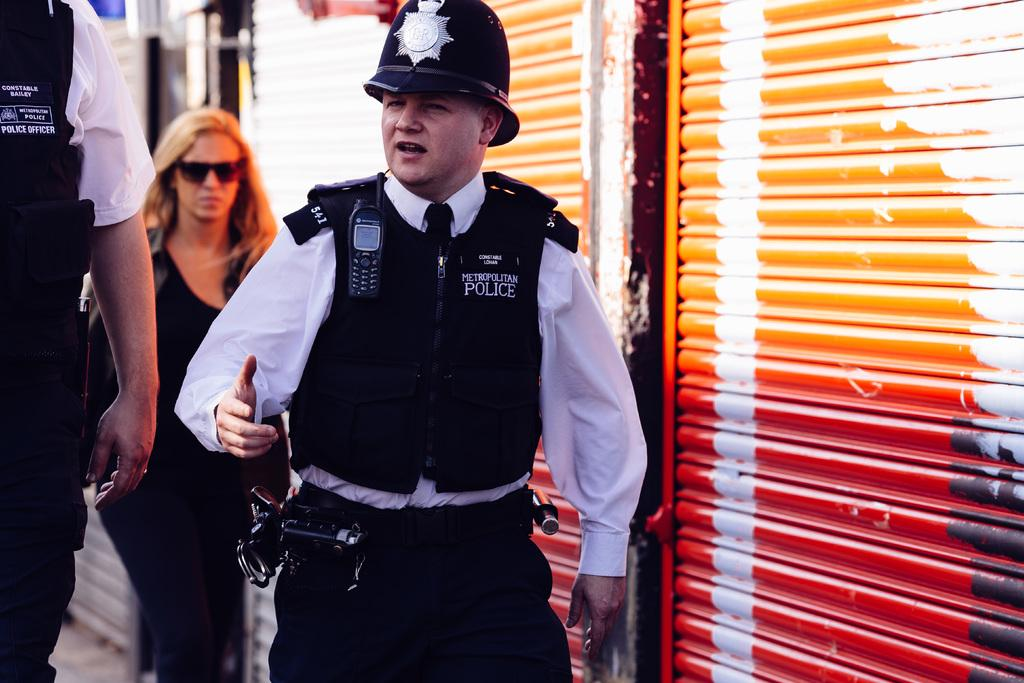How many policemen are in the image? There are two policemen in the image. What is the position of the woman in relation to the policemen? The woman is behind the policemen in the image. What architectural feature can be seen on the right side of the image? There are shutters on the right side of the image. Can you see any cobwebs in the image? There is no mention of cobwebs in the image, so we cannot determine if any are present. 